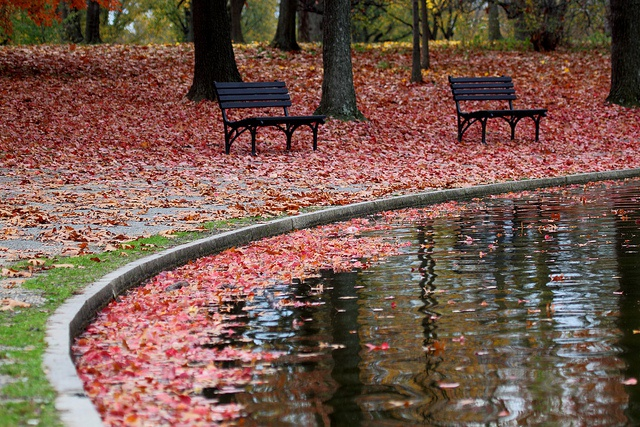Describe the objects in this image and their specific colors. I can see bench in maroon, black, brown, and navy tones and bench in maroon, black, navy, and brown tones in this image. 